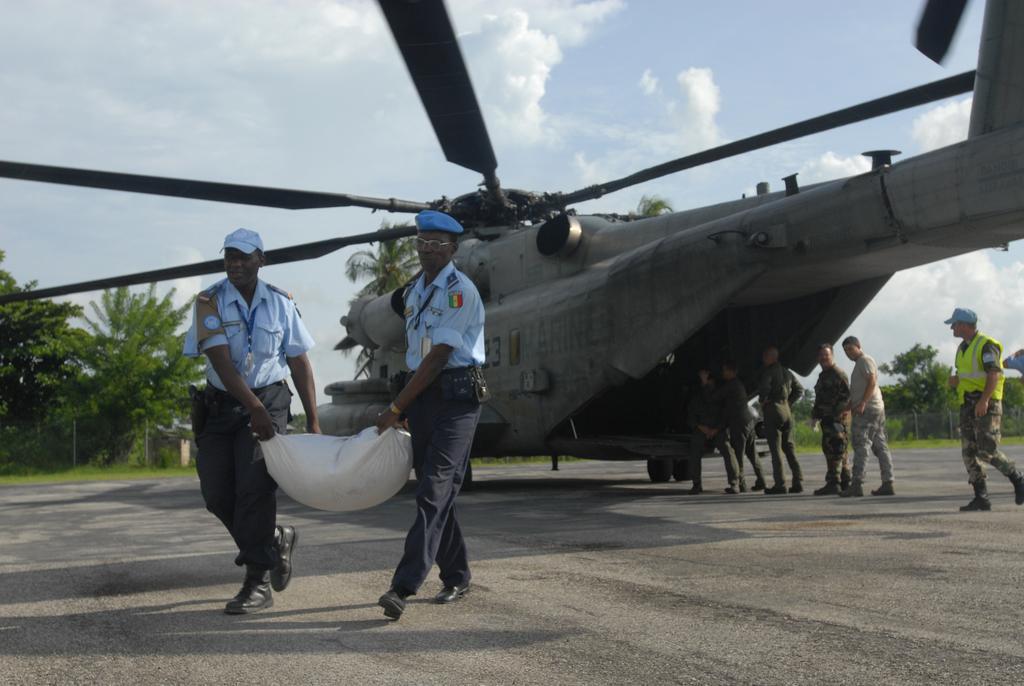Please provide a concise description of this image. In the image there is a helicopter on the road with few men going inside it, in the front there are two officers carrying a bag, in the back there are trees on the grassland and above its sky with clouds. 